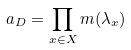<formula> <loc_0><loc_0><loc_500><loc_500>a _ { D } = \prod _ { x \in X } m ( \lambda _ { x } )</formula> 